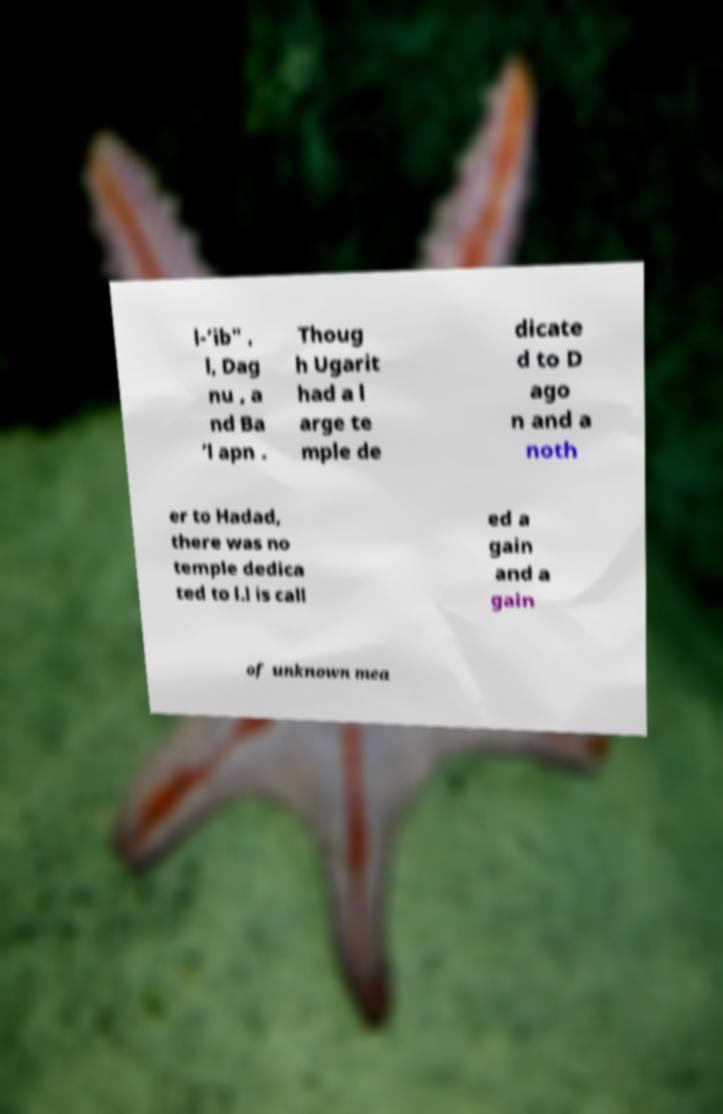For documentation purposes, I need the text within this image transcribed. Could you provide that? l-’ib" , l, Dag nu , a nd Ba ’l apn . Thoug h Ugarit had a l arge te mple de dicate d to D ago n and a noth er to Hadad, there was no temple dedica ted to l.l is call ed a gain and a gain of unknown mea 